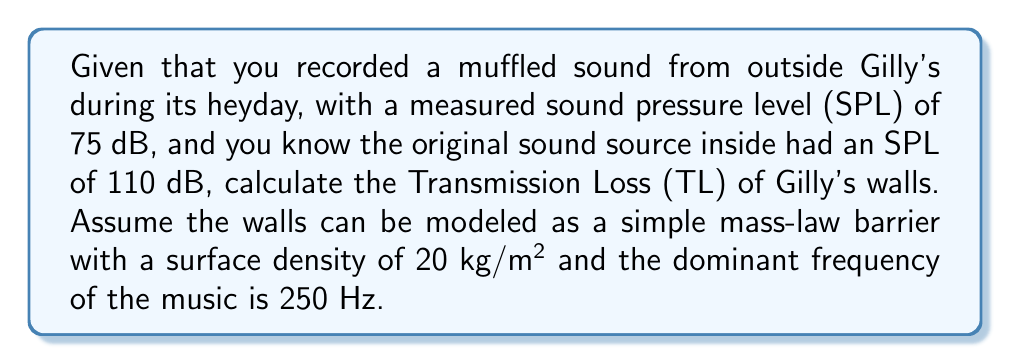What is the answer to this math problem? To solve this problem, we'll follow these steps:

1. Calculate the Transmission Loss (TL) based on the measured SPLs:
   $$ TL = SPL_{inside} - SPL_{outside} $$
   $$ TL = 110 \text{ dB} - 75 \text{ dB} = 35 \text{ dB} $$

2. Use the mass-law equation to verify if this TL is consistent with the wall properties:
   $$ TL_{mass-law} = 20 \log_{10}(fm) - 47 $$
   Where:
   $f$ = frequency in Hz
   $m$ = surface density in kg/m²

3. Substitute the given values:
   $$ TL_{mass-law} = 20 \log_{10}(250 \cdot 20) - 47 $$
   $$ TL_{mass-law} = 20 \log_{10}(5000) - 47 $$
   $$ TL_{mass-law} = 20 \cdot 3.699 - 47 $$
   $$ TL_{mass-law} = 73.98 - 47 = 26.98 \text{ dB} $$

4. Compare the calculated TL with the mass-law prediction:
   The actual TL (35 dB) is higher than the mass-law prediction (26.98 dB), which suggests that Gilly's walls have additional sound insulation properties beyond simple mass-law behavior, such as damping or multi-layer construction.

5. Calculate the difference:
   $$ \Delta TL = TL_{actual} - TL_{mass-law} $$
   $$ \Delta TL = 35 \text{ dB} - 26.98 \text{ dB} = 8.02 \text{ dB} $$

This difference represents the additional acoustic performance of Gilly's walls beyond what would be expected from a simple mass-law barrier.
Answer: 35 dB; 8.02 dB above mass-law prediction 